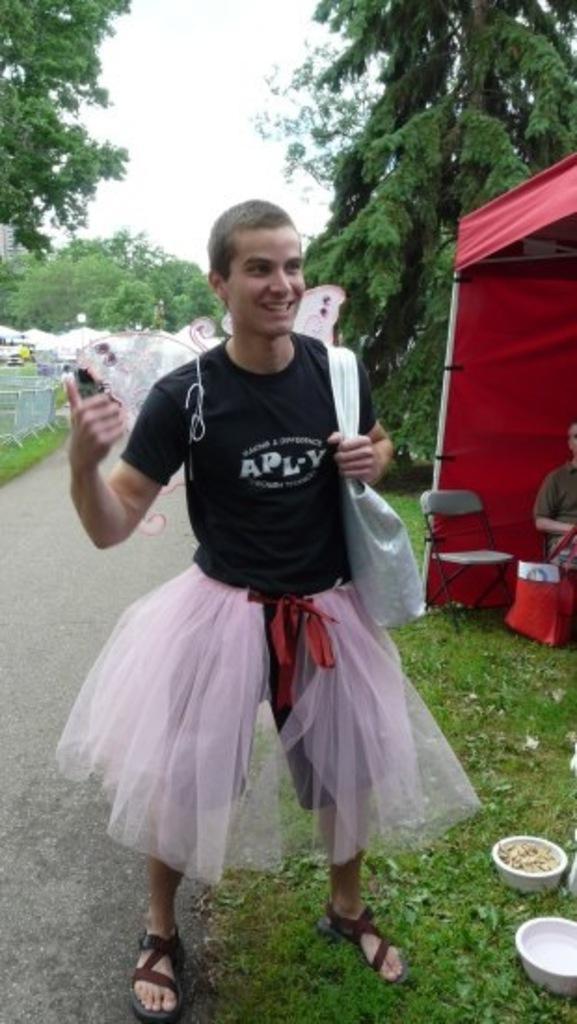Can you describe this image briefly? In this image in front there is a person wearing a smile on his face. Beside him there are bowls. Behind him there is a person sitting on the chair under the tent. Beside him there is another chair. In the center of the image there is a road. In the background of the image there are tents, chairs, trees, buildings and sky. 